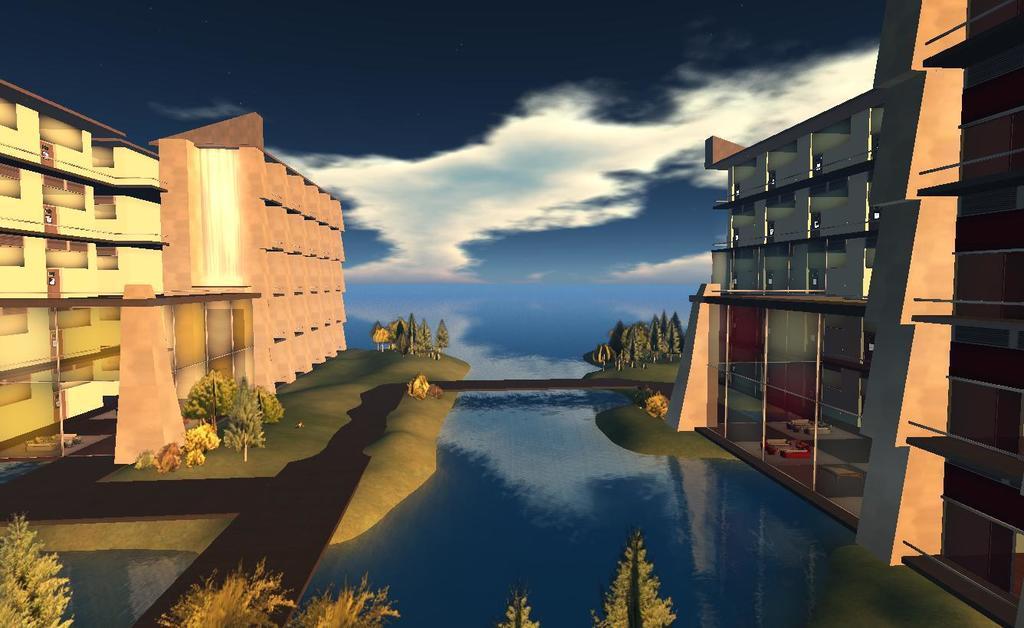Could you give a brief overview of what you see in this image? This is an animated image. At the bottom of the picture, we see trees and water. On either side of the picture, there are trees and buildings. At the top of the picture, we see the sky and the clouds. 